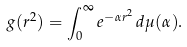Convert formula to latex. <formula><loc_0><loc_0><loc_500><loc_500>g ( r ^ { 2 } ) = \int _ { 0 } ^ { \infty } e ^ { - \alpha r ^ { 2 } } \, d \mu ( \alpha ) .</formula> 